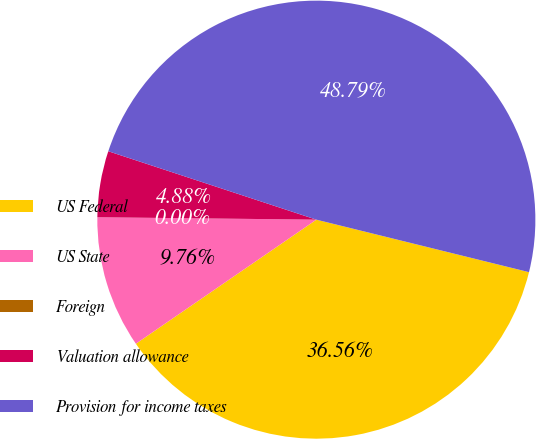<chart> <loc_0><loc_0><loc_500><loc_500><pie_chart><fcel>US Federal<fcel>US State<fcel>Foreign<fcel>Valuation allowance<fcel>Provision for income taxes<nl><fcel>36.56%<fcel>9.76%<fcel>0.0%<fcel>4.88%<fcel>48.79%<nl></chart> 